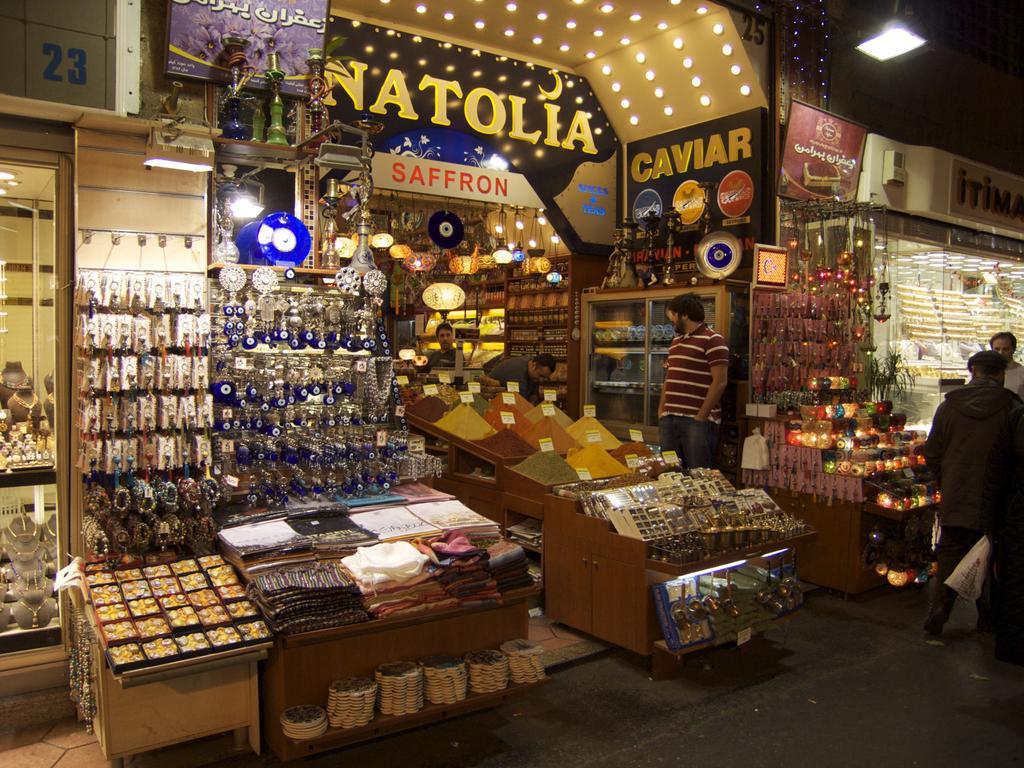Describe this image in one or two sentences. In this picture we can see stores, there are some people standing on the right side, on the left side we can see watches, some jewelry, clothes decorative things and some other things, on the right side we can see price tags, spoons, steel things and other things, there is a hoarding here, we can see lights at the top of the picture, we can see paper lanterns in the middle. 